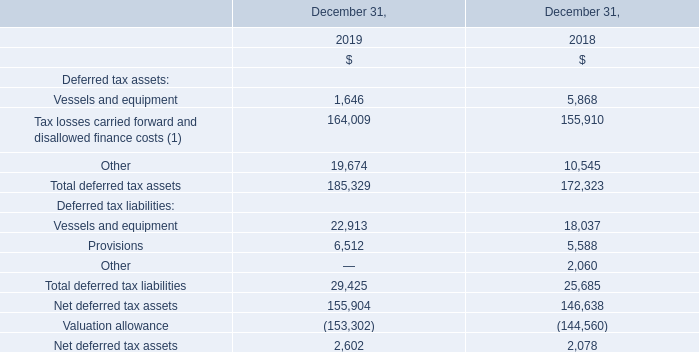22. Income Taxes
Teekay and a majority of its subsidiaries are not subject to income tax in the jurisdictions in which they are incorporated because they do not conduct business or operate in those jurisdictions. However, among others, the Company’s U.K. and Norwegian subsidiaries are subject to income taxes.
The significant components of the Company’s deferred tax assets and liabilities are as follows:
(1) Substantially all of the Company's estimated net operating loss carryforwards of $878.3 million relates primarily to its U.K., Spanish, Norwegian and Luxembourg subsidiaries and, to a lesser extent, to its Australian subsidiaries.
The Company had estimated disallowed finance costs in Spain and Norway of approximately $15.1 million and $15.0 million, respectively, at December 31, 2019, which are available for 18 years and 10 years, respectively, from the year the costs are incurred for offset against future taxable income in Spain and Norway, respectively. The Company's estimated tax losses in Luxembourg are available for offset against taxable future income in Luxembourg, either indefinitely for losses arising prior to 2017, or for 17 years for losses arising subsequent to 2016.
Which subsidiaries are related to  net operating loss carryforwards of $878.3 million? Company's estimated net operating loss carryforwards of $878.3 million relates primarily to its u.k., spanish, norwegian and luxembourg subsidiaries and, to a lesser extent, to its australian subsidiaries. How much is the estimated disallowed finance costs in Spain and Norway at December 31, 2019? The company had estimated disallowed finance costs in spain and norway of approximately $15.1 million and $15.0 million, respectively, at december 31, 2019. Which subsidiaries are subject to income taxes? The company’s u.k. and norwegian subsidiaries are subject to income taxes. What is the increase/ (decrease) in Deferred tax assets: Vessels and equipment from December 31, 2019 to December 31, 2018?
Answer scale should be: million. 1,646-5,868
Answer: -4222. What is the increase/ (decrease) in Deferred tax assets: Tax losses carried forward and disallowed finance costs from December 31, 2019 to December 31, 2018?
Answer scale should be: million. 164,009-155,910
Answer: 8099. What is the increase/ (decrease) in Deferred tax assets: Other from December 31, 2019 to December 31, 2018?
Answer scale should be: million. 19,674-10,545
Answer: 9129. 